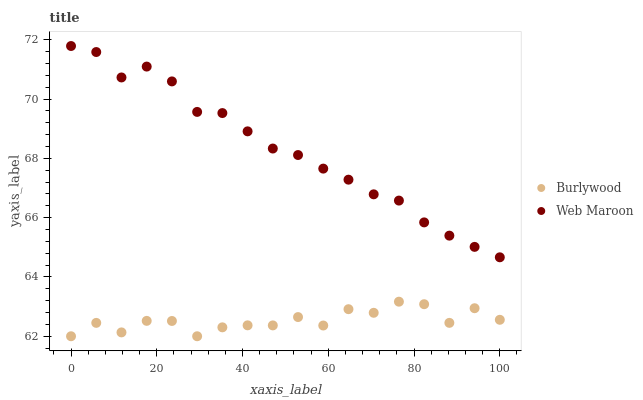Does Burlywood have the minimum area under the curve?
Answer yes or no. Yes. Does Web Maroon have the maximum area under the curve?
Answer yes or no. Yes. Does Web Maroon have the minimum area under the curve?
Answer yes or no. No. Is Web Maroon the smoothest?
Answer yes or no. Yes. Is Burlywood the roughest?
Answer yes or no. Yes. Is Web Maroon the roughest?
Answer yes or no. No. Does Burlywood have the lowest value?
Answer yes or no. Yes. Does Web Maroon have the lowest value?
Answer yes or no. No. Does Web Maroon have the highest value?
Answer yes or no. Yes. Is Burlywood less than Web Maroon?
Answer yes or no. Yes. Is Web Maroon greater than Burlywood?
Answer yes or no. Yes. Does Burlywood intersect Web Maroon?
Answer yes or no. No. 